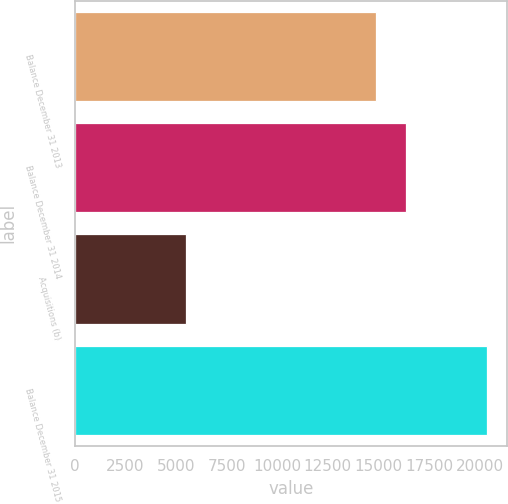Convert chart to OTSL. <chart><loc_0><loc_0><loc_500><loc_500><bar_chart><fcel>Balance December 31 2013<fcel>Balance December 31 2014<fcel>Acquisitions (b)<fcel>Balance December 31 2015<nl><fcel>14882<fcel>16369.7<fcel>5487<fcel>20364<nl></chart> 